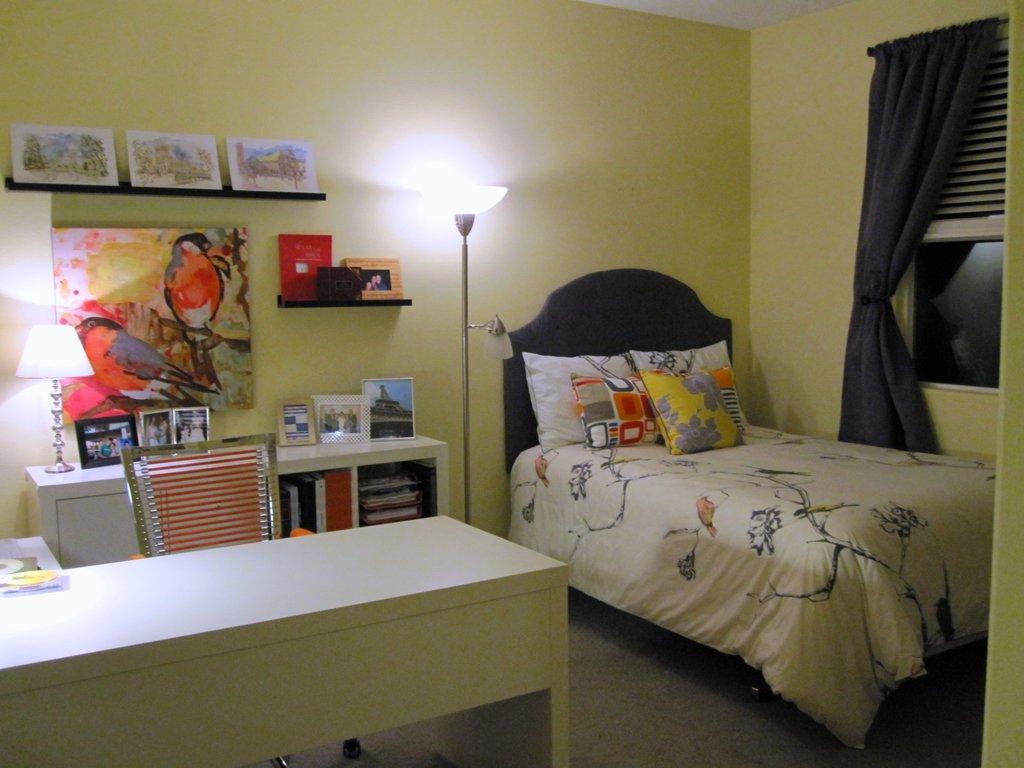Can you describe this image briefly? This is an inside view of a room. On the left side there are two tables and a chair. On the table few photo frames are placed. On the right side there is a bed on which few pillows are placed and there is a curtain to the window. In the background there are few frames attached to the wall. Beside the bed there is a lamp. 